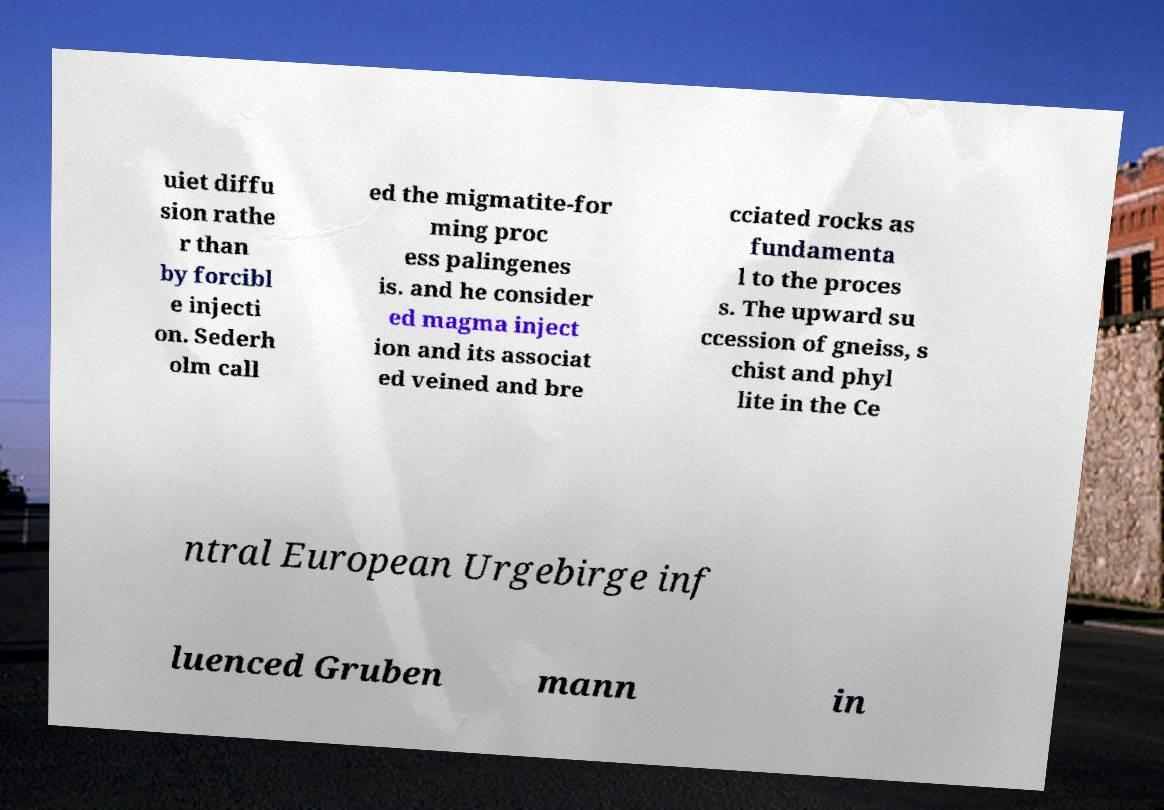Can you read and provide the text displayed in the image?This photo seems to have some interesting text. Can you extract and type it out for me? uiet diffu sion rathe r than by forcibl e injecti on. Sederh olm call ed the migmatite-for ming proc ess palingenes is. and he consider ed magma inject ion and its associat ed veined and bre cciated rocks as fundamenta l to the proces s. The upward su ccession of gneiss, s chist and phyl lite in the Ce ntral European Urgebirge inf luenced Gruben mann in 